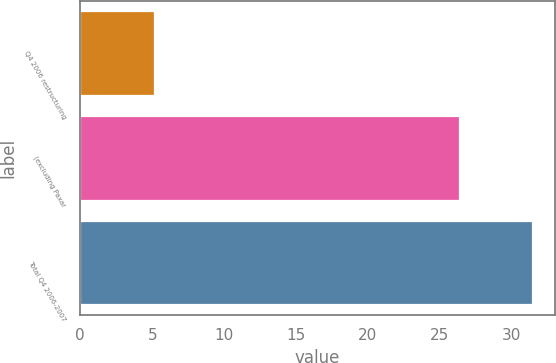Convert chart to OTSL. <chart><loc_0><loc_0><loc_500><loc_500><bar_chart><fcel>Q4 2006 restructuring<fcel>(excluding Paxar<fcel>Total Q4 2006-2007<nl><fcel>5.1<fcel>26.3<fcel>31.4<nl></chart> 